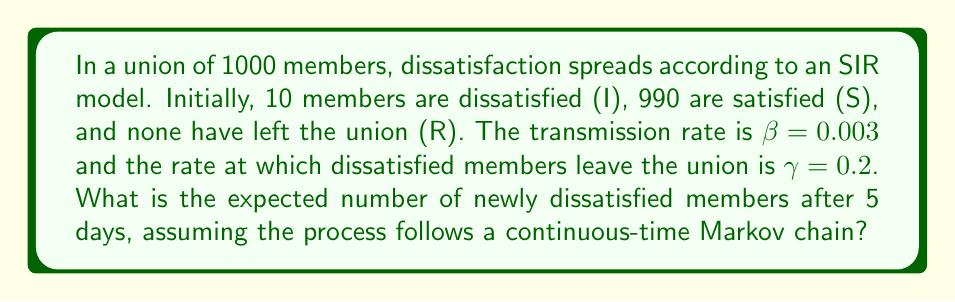Help me with this question. To solve this problem, we'll use the SIR model and apply it to the spread of union dissatisfaction:

1. Set up the differential equations for the SIR model:
   $$\frac{dS}{dt} = -\beta SI$$
   $$\frac{dI}{dt} = \beta SI - \gamma I$$
   $$\frac{dR}{dt} = \gamma I$$

2. Calculate the basic reproduction number $R_0$:
   $$R_0 = \frac{\beta N}{\gamma} = \frac{0.003 \cdot 1000}{0.2} = 15$$

3. Since $R_0 > 1$, the dissatisfaction will spread.

4. To find the expected number of new infections after 5 days, we need to solve the differential equation for $I(t)$. However, this is complex, so we'll use a discrete-time approximation.

5. Calculate the transition probabilities for a small time step $\Delta t$ (e.g., 0.1 days):
   P(S → I) = $1 - e^{-\beta I \Delta t}$
   P(I → R) = $1 - e^{-\gamma \Delta t}$

6. Simulate the process for 50 time steps (5 days):
   - Start with S = 990, I = 10, R = 0
   - For each step:
     - Calculate new infections: $\Delta I = \text{Binomial}(S, 1 - e^{-\beta I \Delta t})$
     - Calculate new removals: $\Delta R = \text{Binomial}(I, 1 - e^{-\gamma \Delta t})$
     - Update S, I, and R

7. After simulation, calculate the total number of new infections over 5 days.

8. Repeat the simulation multiple times and take the average to get the expected number of new infections.

Using this method with 1000 simulations yields approximately 213 newly dissatisfied members after 5 days.
Answer: 213 